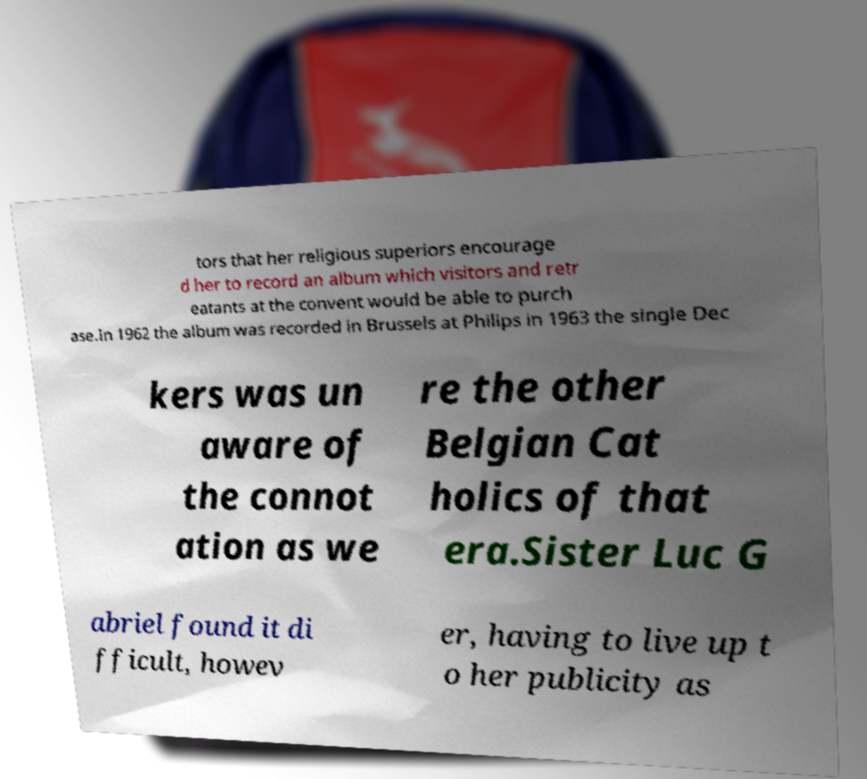Please read and relay the text visible in this image. What does it say? tors that her religious superiors encourage d her to record an album which visitors and retr eatants at the convent would be able to purch ase.In 1962 the album was recorded in Brussels at Philips in 1963 the single Dec kers was un aware of the connot ation as we re the other Belgian Cat holics of that era.Sister Luc G abriel found it di fficult, howev er, having to live up t o her publicity as 